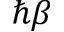<formula> <loc_0><loc_0><loc_500><loc_500>\hbar { \beta }</formula> 